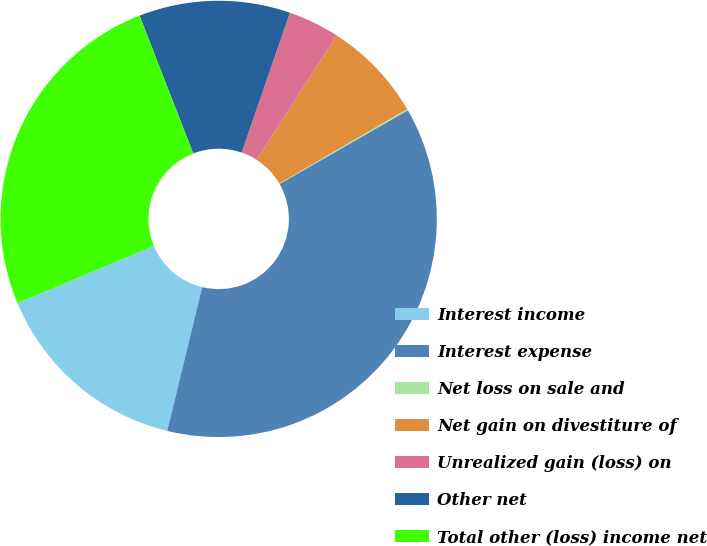Convert chart. <chart><loc_0><loc_0><loc_500><loc_500><pie_chart><fcel>Interest income<fcel>Interest expense<fcel>Net loss on sale and<fcel>Net gain on divestiture of<fcel>Unrealized gain (loss) on<fcel>Other net<fcel>Total other (loss) income net<nl><fcel>14.9%<fcel>37.08%<fcel>0.11%<fcel>7.5%<fcel>3.8%<fcel>11.2%<fcel>25.4%<nl></chart> 